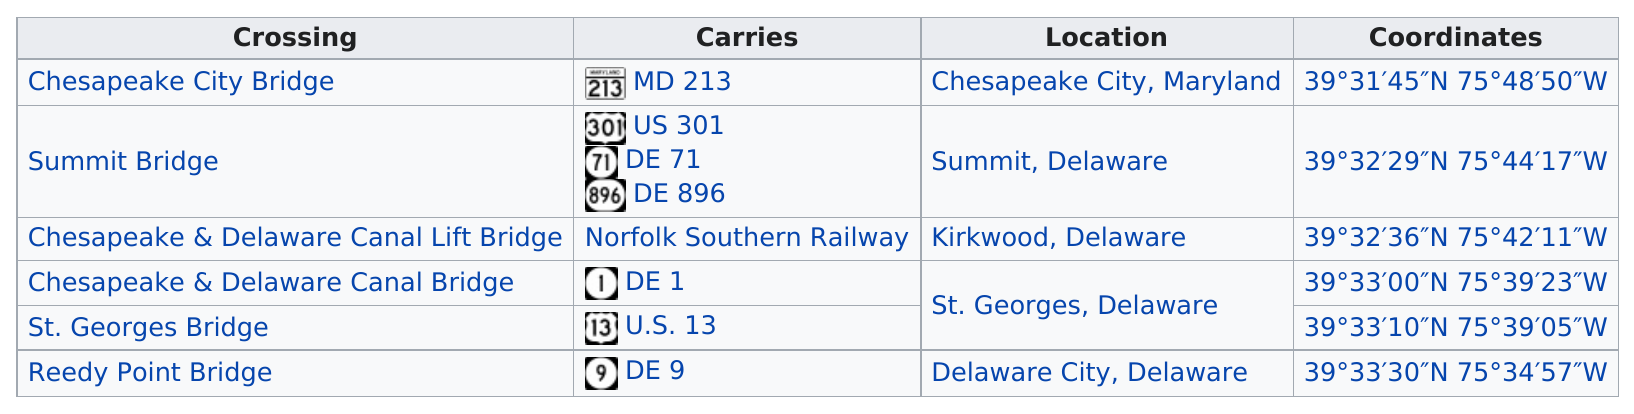Indicate a few pertinent items in this graphic. The Reedy Point Bridge in Delaware is a structure that carries DE 9 and is located in that state. The Summit Bridge, located in Summit, Delaware, has its location in Summit, Delaware. There is at least one crossing in the state of Maryland. The question asks which crossing carries the most routes, specifically referring to the de 1. The speaker says they will describe the Summit Bridge, which carries many busy routes, including the de 1. 